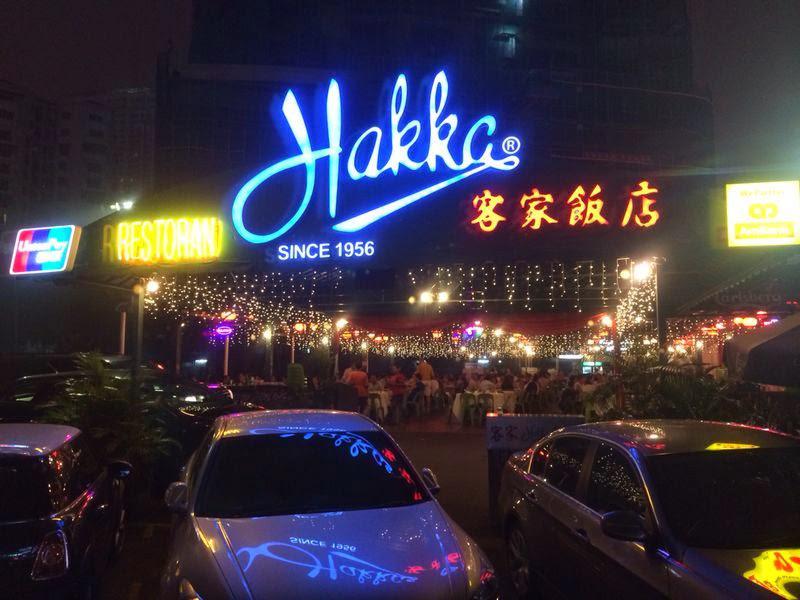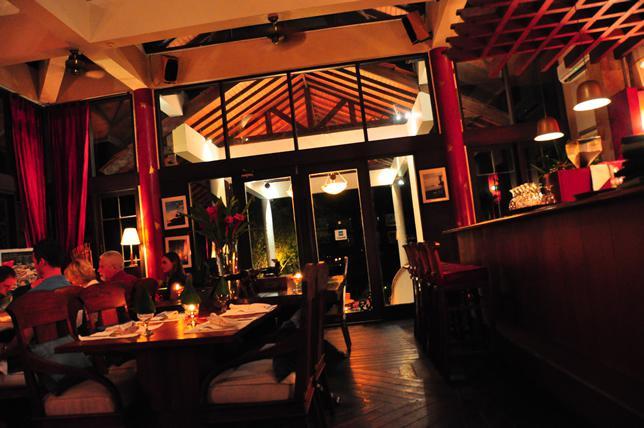The first image is the image on the left, the second image is the image on the right. Evaluate the accuracy of this statement regarding the images: "In at least one image there are bar supplies on a wooden two tone bar with the top being dark brown.". Is it true? Answer yes or no. No. The first image is the image on the left, the second image is the image on the right. Analyze the images presented: Is the assertion "One image is of the inside of a business and the other is of the outside of a business." valid? Answer yes or no. Yes. 